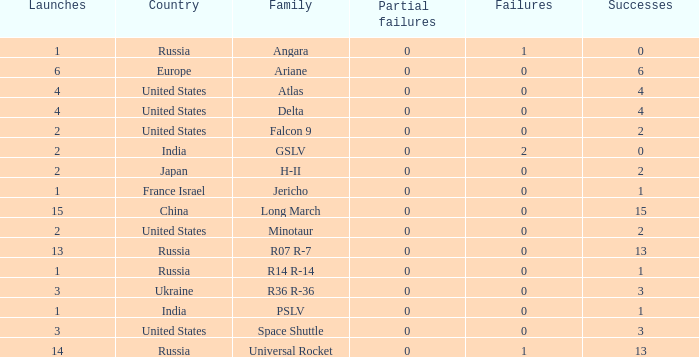Give me the full table as a dictionary. {'header': ['Launches', 'Country', 'Family', 'Partial failures', 'Failures', 'Successes'], 'rows': [['1', 'Russia', 'Angara', '0', '1', '0'], ['6', 'Europe', 'Ariane', '0', '0', '6'], ['4', 'United States', 'Atlas', '0', '0', '4'], ['4', 'United States', 'Delta', '0', '0', '4'], ['2', 'United States', 'Falcon 9', '0', '0', '2'], ['2', 'India', 'GSLV', '0', '2', '0'], ['2', 'Japan', 'H-II', '0', '0', '2'], ['1', 'France Israel', 'Jericho', '0', '0', '1'], ['15', 'China', 'Long March', '0', '0', '15'], ['2', 'United States', 'Minotaur', '0', '0', '2'], ['13', 'Russia', 'R07 R-7', '0', '0', '13'], ['1', 'Russia', 'R14 R-14', '0', '0', '1'], ['3', 'Ukraine', 'R36 R-36', '0', '0', '3'], ['1', 'India', 'PSLV', '0', '0', '1'], ['3', 'United States', 'Space Shuttle', '0', '0', '3'], ['14', 'Russia', 'Universal Rocket', '0', '1', '13']]} What is the number of failure for the country of Russia, and a Family of r14 r-14, and a Partial failures smaller than 0? 0.0. 